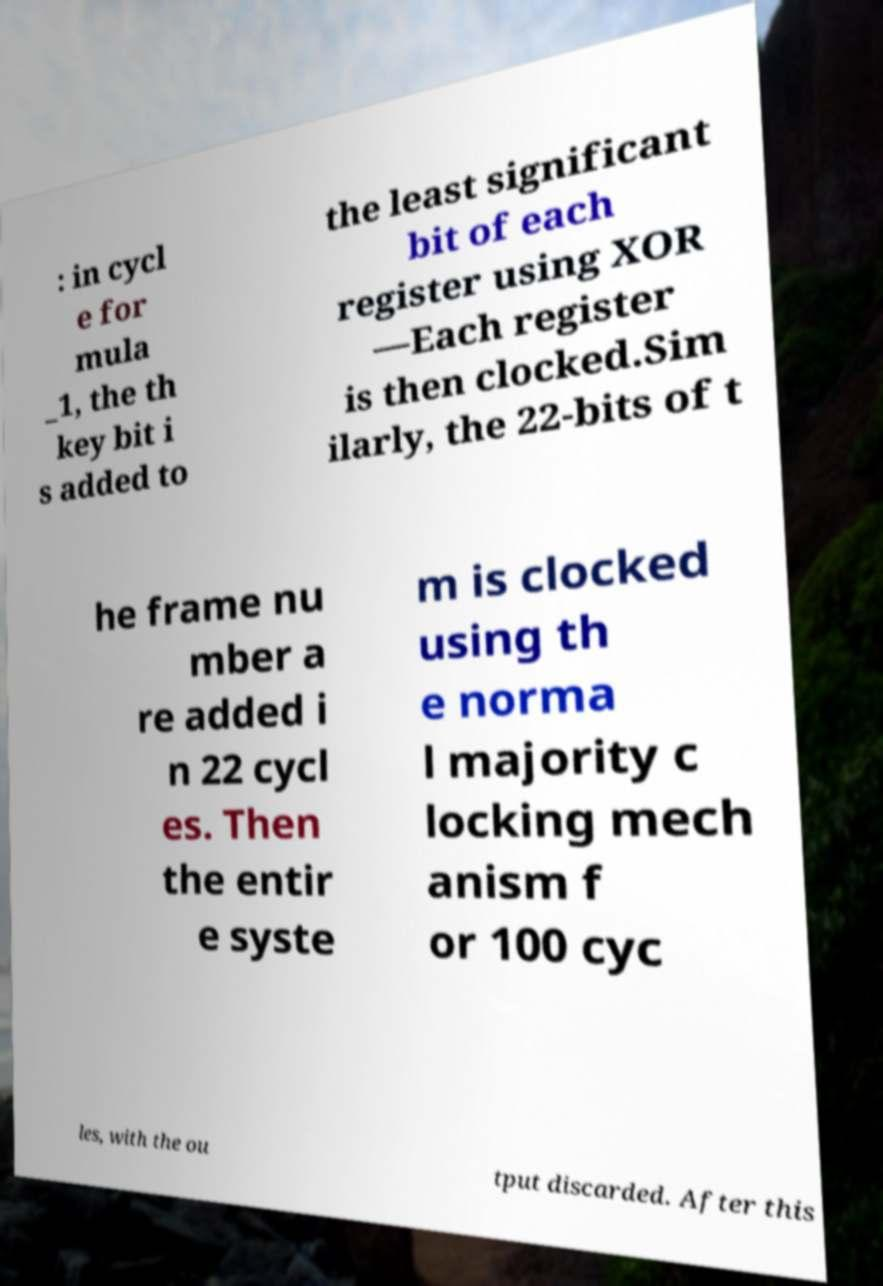Can you accurately transcribe the text from the provided image for me? : in cycl e for mula _1, the th key bit i s added to the least significant bit of each register using XOR —Each register is then clocked.Sim ilarly, the 22-bits of t he frame nu mber a re added i n 22 cycl es. Then the entir e syste m is clocked using th e norma l majority c locking mech anism f or 100 cyc les, with the ou tput discarded. After this 